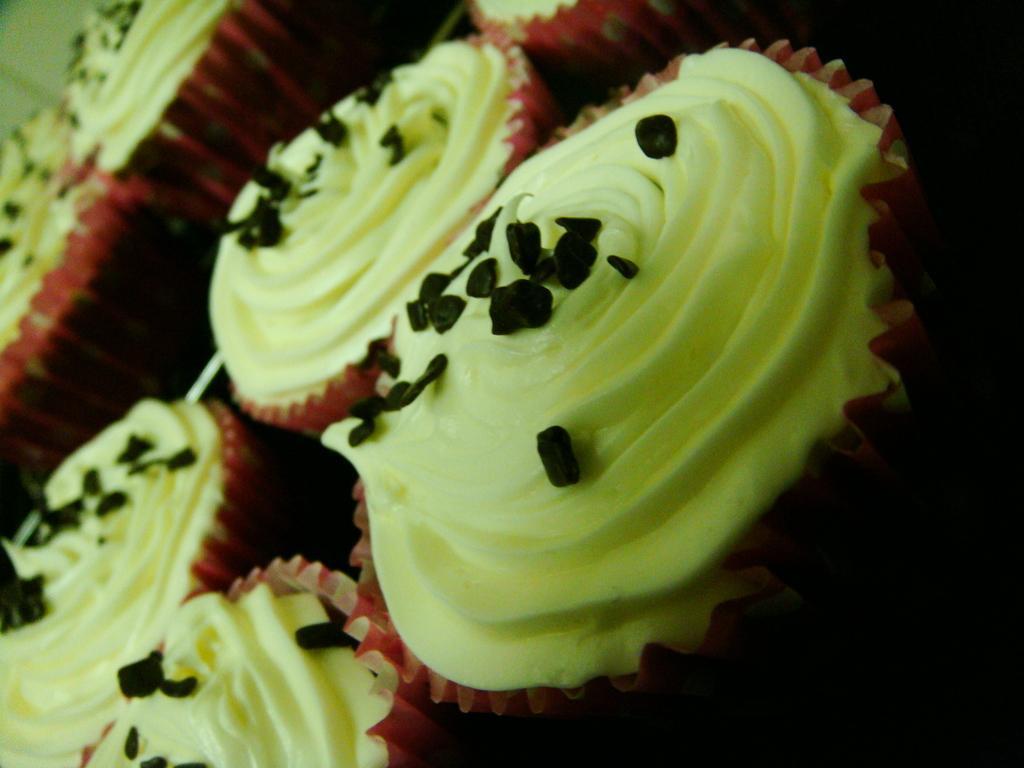In one or two sentences, can you explain what this image depicts? In this image we can see a few cupcakes and some chocolate chips on the cake. 